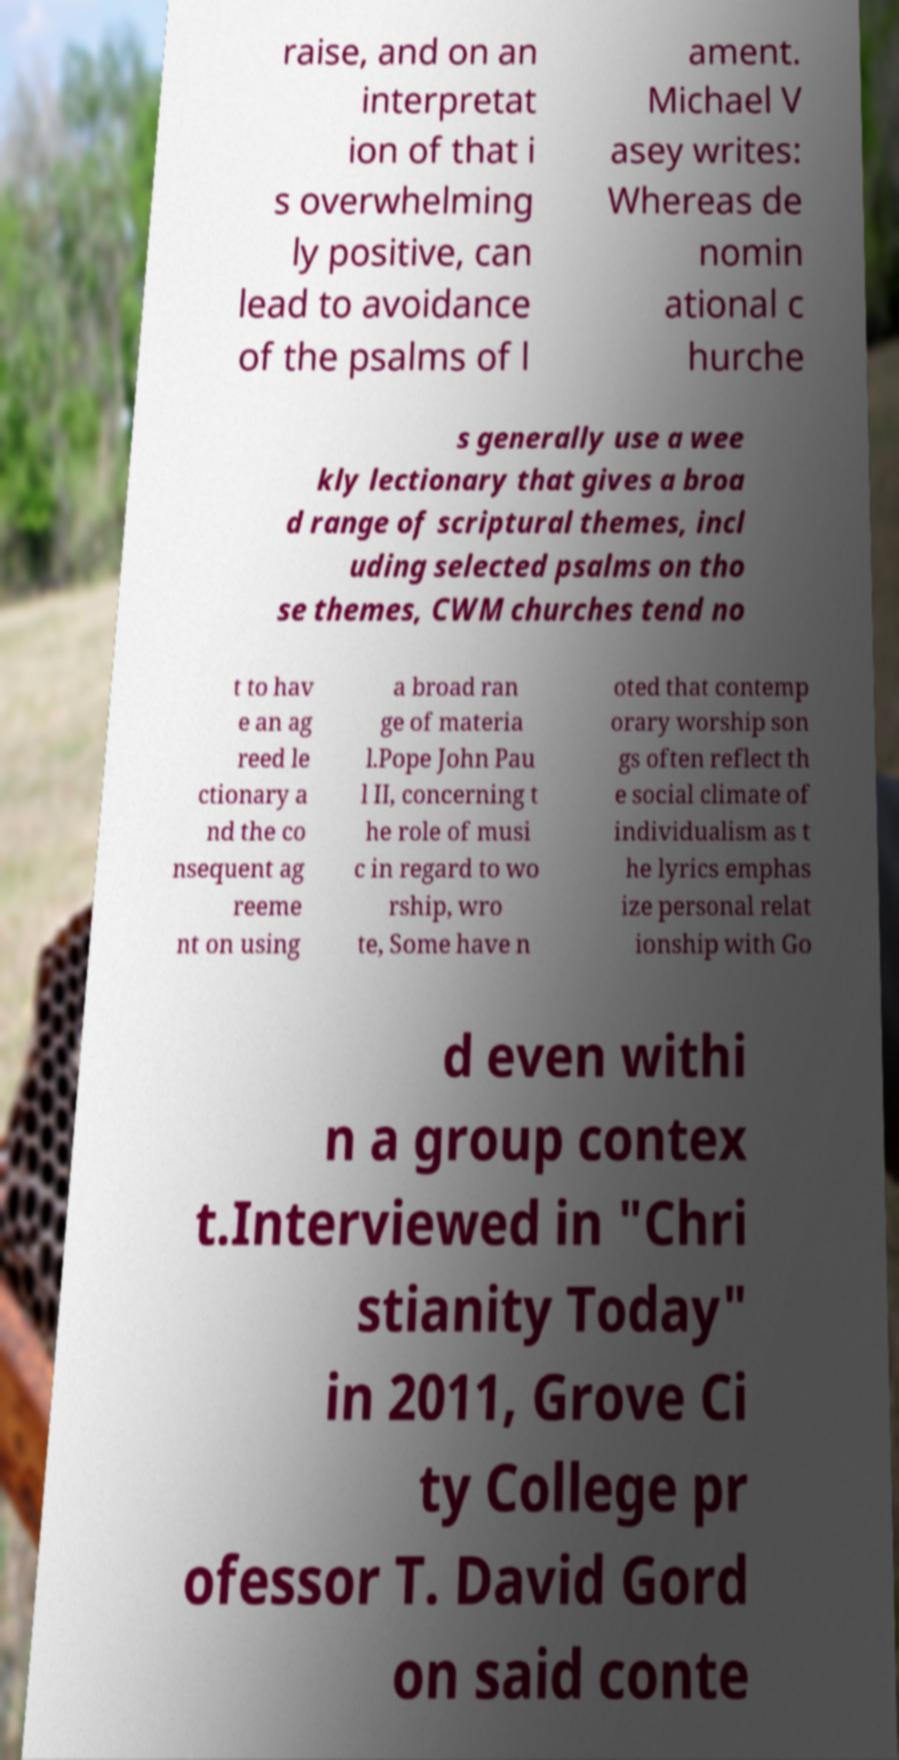Please read and relay the text visible in this image. What does it say? raise, and on an interpretat ion of that i s overwhelming ly positive, can lead to avoidance of the psalms of l ament. Michael V asey writes: Whereas de nomin ational c hurche s generally use a wee kly lectionary that gives a broa d range of scriptural themes, incl uding selected psalms on tho se themes, CWM churches tend no t to hav e an ag reed le ctionary a nd the co nsequent ag reeme nt on using a broad ran ge of materia l.Pope John Pau l II, concerning t he role of musi c in regard to wo rship, wro te, Some have n oted that contemp orary worship son gs often reflect th e social climate of individualism as t he lyrics emphas ize personal relat ionship with Go d even withi n a group contex t.Interviewed in "Chri stianity Today" in 2011, Grove Ci ty College pr ofessor T. David Gord on said conte 